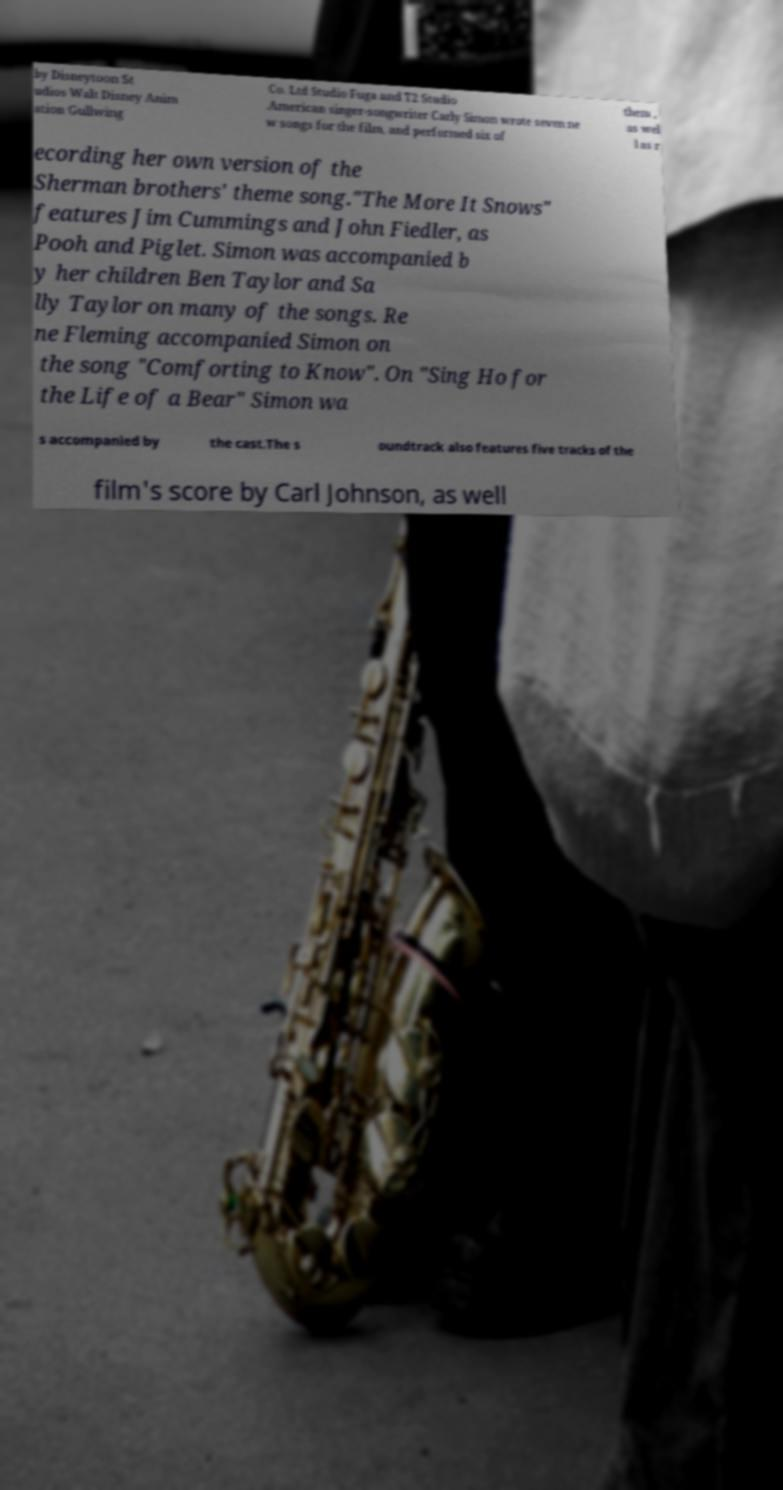Please identify and transcribe the text found in this image. by Disneytoon St udios Walt Disney Anim ation Gullwing Co. Ltd Studio Fuga and T2 Studio .American singer-songwriter Carly Simon wrote seven ne w songs for the film, and performed six of them , as wel l as r ecording her own version of the Sherman brothers' theme song."The More It Snows" features Jim Cummings and John Fiedler, as Pooh and Piglet. Simon was accompanied b y her children Ben Taylor and Sa lly Taylor on many of the songs. Re ne Fleming accompanied Simon on the song "Comforting to Know". On "Sing Ho for the Life of a Bear" Simon wa s accompanied by the cast.The s oundtrack also features five tracks of the film's score by Carl Johnson, as well 